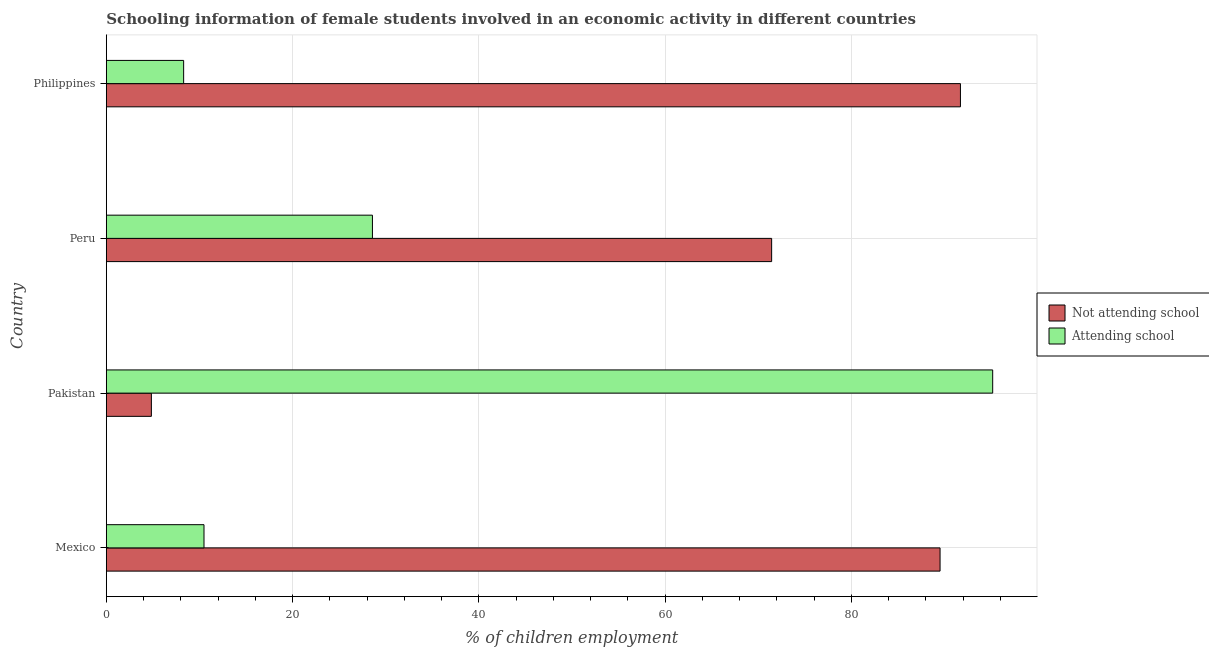How many different coloured bars are there?
Give a very brief answer. 2. What is the label of the 2nd group of bars from the top?
Your answer should be very brief. Peru. What is the percentage of employed females who are attending school in Pakistan?
Ensure brevity in your answer.  95.16. Across all countries, what is the maximum percentage of employed females who are attending school?
Provide a short and direct response. 95.16. In which country was the percentage of employed females who are not attending school maximum?
Ensure brevity in your answer.  Philippines. What is the total percentage of employed females who are not attending school in the graph?
Make the answer very short. 257.48. What is the difference between the percentage of employed females who are attending school in Pakistan and that in Peru?
Your response must be concise. 66.59. What is the difference between the percentage of employed females who are not attending school in Philippines and the percentage of employed females who are attending school in Peru?
Offer a terse response. 63.13. What is the average percentage of employed females who are attending school per country?
Offer a very short reply. 35.63. What is the difference between the percentage of employed females who are attending school and percentage of employed females who are not attending school in Peru?
Ensure brevity in your answer.  -42.86. What is the ratio of the percentage of employed females who are not attending school in Pakistan to that in Peru?
Offer a very short reply. 0.07. Is the percentage of employed females who are not attending school in Mexico less than that in Philippines?
Make the answer very short. Yes. What is the difference between the highest and the second highest percentage of employed females who are attending school?
Ensure brevity in your answer.  66.59. What is the difference between the highest and the lowest percentage of employed females who are not attending school?
Your answer should be very brief. 86.86. In how many countries, is the percentage of employed females who are not attending school greater than the average percentage of employed females who are not attending school taken over all countries?
Ensure brevity in your answer.  3. Is the sum of the percentage of employed females who are not attending school in Mexico and Peru greater than the maximum percentage of employed females who are attending school across all countries?
Your answer should be very brief. Yes. What does the 2nd bar from the top in Pakistan represents?
Your response must be concise. Not attending school. What does the 1st bar from the bottom in Pakistan represents?
Keep it short and to the point. Not attending school. How many countries are there in the graph?
Provide a succinct answer. 4. What is the difference between two consecutive major ticks on the X-axis?
Give a very brief answer. 20. Are the values on the major ticks of X-axis written in scientific E-notation?
Your answer should be compact. No. Where does the legend appear in the graph?
Your answer should be compact. Center right. How many legend labels are there?
Give a very brief answer. 2. What is the title of the graph?
Ensure brevity in your answer.  Schooling information of female students involved in an economic activity in different countries. Does "Sanitation services" appear as one of the legend labels in the graph?
Ensure brevity in your answer.  No. What is the label or title of the X-axis?
Give a very brief answer. % of children employment. What is the % of children employment of Not attending school in Mexico?
Offer a terse response. 89.51. What is the % of children employment in Attending school in Mexico?
Provide a succinct answer. 10.49. What is the % of children employment in Not attending school in Pakistan?
Offer a terse response. 4.84. What is the % of children employment in Attending school in Pakistan?
Give a very brief answer. 95.16. What is the % of children employment of Not attending school in Peru?
Offer a terse response. 71.43. What is the % of children employment of Attending school in Peru?
Offer a very short reply. 28.57. What is the % of children employment in Not attending school in Philippines?
Provide a succinct answer. 91.7. Across all countries, what is the maximum % of children employment in Not attending school?
Give a very brief answer. 91.7. Across all countries, what is the maximum % of children employment in Attending school?
Your answer should be very brief. 95.16. Across all countries, what is the minimum % of children employment of Not attending school?
Your answer should be very brief. 4.84. Across all countries, what is the minimum % of children employment of Attending school?
Provide a succinct answer. 8.3. What is the total % of children employment in Not attending school in the graph?
Your answer should be very brief. 257.48. What is the total % of children employment in Attending school in the graph?
Offer a terse response. 142.52. What is the difference between the % of children employment of Not attending school in Mexico and that in Pakistan?
Ensure brevity in your answer.  84.68. What is the difference between the % of children employment of Attending school in Mexico and that in Pakistan?
Make the answer very short. -84.68. What is the difference between the % of children employment of Not attending school in Mexico and that in Peru?
Offer a terse response. 18.08. What is the difference between the % of children employment in Attending school in Mexico and that in Peru?
Ensure brevity in your answer.  -18.08. What is the difference between the % of children employment of Not attending school in Mexico and that in Philippines?
Offer a terse response. -2.19. What is the difference between the % of children employment in Attending school in Mexico and that in Philippines?
Provide a succinct answer. 2.19. What is the difference between the % of children employment of Not attending school in Pakistan and that in Peru?
Ensure brevity in your answer.  -66.59. What is the difference between the % of children employment in Attending school in Pakistan and that in Peru?
Provide a short and direct response. 66.59. What is the difference between the % of children employment in Not attending school in Pakistan and that in Philippines?
Your answer should be compact. -86.86. What is the difference between the % of children employment of Attending school in Pakistan and that in Philippines?
Your answer should be compact. 86.86. What is the difference between the % of children employment in Not attending school in Peru and that in Philippines?
Give a very brief answer. -20.27. What is the difference between the % of children employment in Attending school in Peru and that in Philippines?
Your response must be concise. 20.27. What is the difference between the % of children employment in Not attending school in Mexico and the % of children employment in Attending school in Pakistan?
Ensure brevity in your answer.  -5.65. What is the difference between the % of children employment in Not attending school in Mexico and the % of children employment in Attending school in Peru?
Ensure brevity in your answer.  60.94. What is the difference between the % of children employment in Not attending school in Mexico and the % of children employment in Attending school in Philippines?
Offer a very short reply. 81.21. What is the difference between the % of children employment of Not attending school in Pakistan and the % of children employment of Attending school in Peru?
Keep it short and to the point. -23.73. What is the difference between the % of children employment in Not attending school in Pakistan and the % of children employment in Attending school in Philippines?
Give a very brief answer. -3.46. What is the difference between the % of children employment in Not attending school in Peru and the % of children employment in Attending school in Philippines?
Make the answer very short. 63.13. What is the average % of children employment of Not attending school per country?
Give a very brief answer. 64.37. What is the average % of children employment of Attending school per country?
Give a very brief answer. 35.63. What is the difference between the % of children employment in Not attending school and % of children employment in Attending school in Mexico?
Make the answer very short. 79.03. What is the difference between the % of children employment of Not attending school and % of children employment of Attending school in Pakistan?
Your answer should be compact. -90.33. What is the difference between the % of children employment in Not attending school and % of children employment in Attending school in Peru?
Give a very brief answer. 42.86. What is the difference between the % of children employment of Not attending school and % of children employment of Attending school in Philippines?
Offer a very short reply. 83.4. What is the ratio of the % of children employment in Not attending school in Mexico to that in Pakistan?
Make the answer very short. 18.51. What is the ratio of the % of children employment of Attending school in Mexico to that in Pakistan?
Your response must be concise. 0.11. What is the ratio of the % of children employment of Not attending school in Mexico to that in Peru?
Offer a terse response. 1.25. What is the ratio of the % of children employment of Attending school in Mexico to that in Peru?
Give a very brief answer. 0.37. What is the ratio of the % of children employment of Not attending school in Mexico to that in Philippines?
Provide a succinct answer. 0.98. What is the ratio of the % of children employment in Attending school in Mexico to that in Philippines?
Provide a succinct answer. 1.26. What is the ratio of the % of children employment in Not attending school in Pakistan to that in Peru?
Keep it short and to the point. 0.07. What is the ratio of the % of children employment of Attending school in Pakistan to that in Peru?
Ensure brevity in your answer.  3.33. What is the ratio of the % of children employment in Not attending school in Pakistan to that in Philippines?
Ensure brevity in your answer.  0.05. What is the ratio of the % of children employment of Attending school in Pakistan to that in Philippines?
Ensure brevity in your answer.  11.47. What is the ratio of the % of children employment of Not attending school in Peru to that in Philippines?
Provide a succinct answer. 0.78. What is the ratio of the % of children employment in Attending school in Peru to that in Philippines?
Offer a terse response. 3.44. What is the difference between the highest and the second highest % of children employment of Not attending school?
Give a very brief answer. 2.19. What is the difference between the highest and the second highest % of children employment in Attending school?
Offer a terse response. 66.59. What is the difference between the highest and the lowest % of children employment in Not attending school?
Provide a short and direct response. 86.86. What is the difference between the highest and the lowest % of children employment of Attending school?
Give a very brief answer. 86.86. 